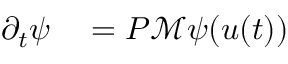<formula> <loc_0><loc_0><loc_500><loc_500>\begin{array} { r l } { \partial _ { t } \psi } & = P \mathcal { M } \psi ( u ( t ) ) } \end{array}</formula> 